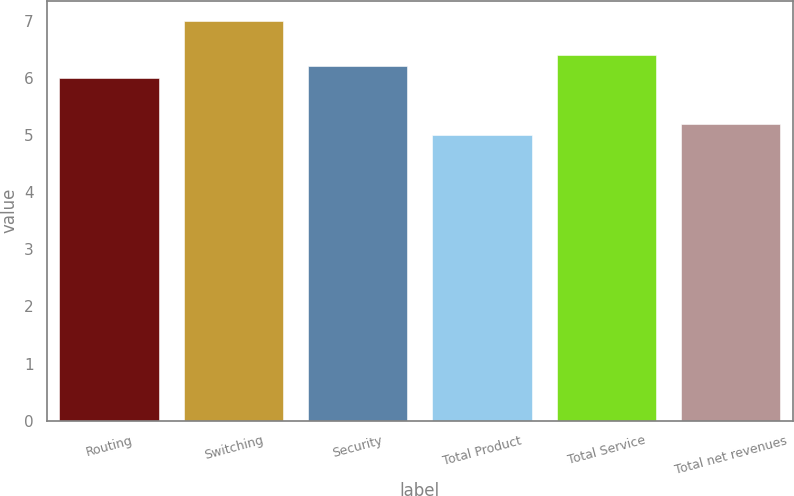Convert chart. <chart><loc_0><loc_0><loc_500><loc_500><bar_chart><fcel>Routing<fcel>Switching<fcel>Security<fcel>Total Product<fcel>Total Service<fcel>Total net revenues<nl><fcel>6<fcel>7<fcel>6.2<fcel>5<fcel>6.4<fcel>5.2<nl></chart> 